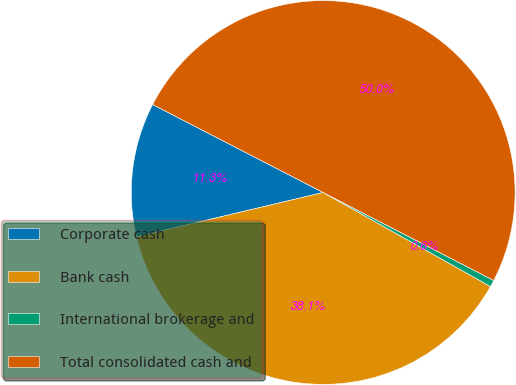Convert chart to OTSL. <chart><loc_0><loc_0><loc_500><loc_500><pie_chart><fcel>Corporate cash<fcel>Bank cash<fcel>International brokerage and<fcel>Total consolidated cash and<nl><fcel>11.29%<fcel>38.14%<fcel>0.57%<fcel>50.0%<nl></chart> 